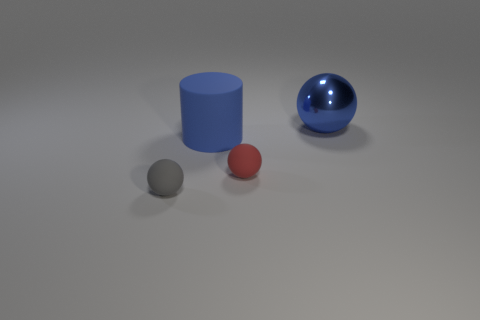Is there anything else that is the same material as the big sphere?
Keep it short and to the point. No. There is a small matte object that is on the left side of the tiny rubber sphere right of the big blue rubber cylinder; are there any small objects that are to the right of it?
Provide a succinct answer. Yes. There is a small thing that is the same material as the tiny red sphere; what is its shape?
Give a very brief answer. Sphere. Is there any other thing that has the same shape as the big matte thing?
Make the answer very short. No. The blue metallic thing is what shape?
Provide a short and direct response. Sphere. Does the rubber object that is left of the blue rubber object have the same shape as the red thing?
Ensure brevity in your answer.  Yes. Is the number of tiny gray spheres in front of the blue cylinder greater than the number of small objects that are in front of the gray matte ball?
Provide a short and direct response. Yes. How many other things are there of the same size as the gray thing?
Make the answer very short. 1. There is a gray matte object; does it have the same shape as the large blue object that is on the right side of the large matte cylinder?
Your answer should be very brief. Yes. What number of metal things are either small red spheres or big things?
Offer a terse response. 1. 